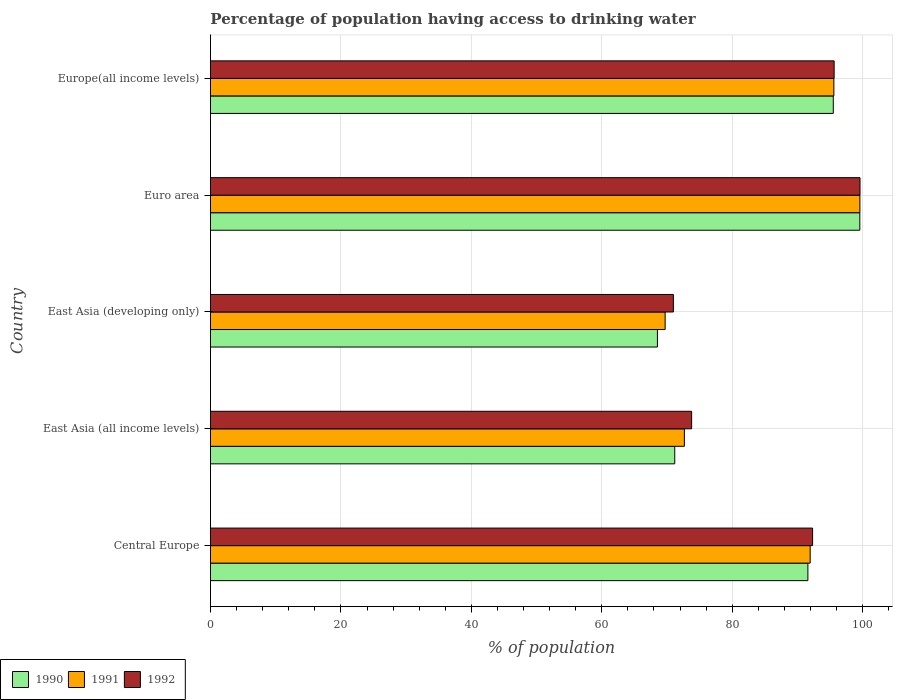How many different coloured bars are there?
Offer a terse response. 3. How many groups of bars are there?
Keep it short and to the point. 5. Are the number of bars on each tick of the Y-axis equal?
Offer a very short reply. Yes. How many bars are there on the 5th tick from the bottom?
Offer a very short reply. 3. What is the label of the 4th group of bars from the top?
Provide a succinct answer. East Asia (all income levels). What is the percentage of population having access to drinking water in 1990 in East Asia (all income levels)?
Provide a succinct answer. 71.19. Across all countries, what is the maximum percentage of population having access to drinking water in 1990?
Keep it short and to the point. 99.57. Across all countries, what is the minimum percentage of population having access to drinking water in 1992?
Your answer should be compact. 70.98. In which country was the percentage of population having access to drinking water in 1990 minimum?
Offer a terse response. East Asia (developing only). What is the total percentage of population having access to drinking water in 1990 in the graph?
Provide a short and direct response. 426.38. What is the difference between the percentage of population having access to drinking water in 1991 in Euro area and that in Europe(all income levels)?
Keep it short and to the point. 3.99. What is the difference between the percentage of population having access to drinking water in 1991 in East Asia (all income levels) and the percentage of population having access to drinking water in 1992 in East Asia (developing only)?
Ensure brevity in your answer.  1.69. What is the average percentage of population having access to drinking water in 1991 per country?
Your response must be concise. 85.9. What is the difference between the percentage of population having access to drinking water in 1990 and percentage of population having access to drinking water in 1992 in East Asia (developing only)?
Give a very brief answer. -2.44. In how many countries, is the percentage of population having access to drinking water in 1990 greater than 76 %?
Make the answer very short. 3. What is the ratio of the percentage of population having access to drinking water in 1992 in East Asia (all income levels) to that in East Asia (developing only)?
Give a very brief answer. 1.04. Is the difference between the percentage of population having access to drinking water in 1990 in Central Europe and East Asia (all income levels) greater than the difference between the percentage of population having access to drinking water in 1992 in Central Europe and East Asia (all income levels)?
Offer a very short reply. Yes. What is the difference between the highest and the second highest percentage of population having access to drinking water in 1992?
Your answer should be very brief. 3.97. What is the difference between the highest and the lowest percentage of population having access to drinking water in 1990?
Keep it short and to the point. 31.03. What does the 2nd bar from the top in Europe(all income levels) represents?
Give a very brief answer. 1991. Are all the bars in the graph horizontal?
Provide a short and direct response. Yes. What is the difference between two consecutive major ticks on the X-axis?
Provide a short and direct response. 20. Does the graph contain grids?
Your response must be concise. Yes. Where does the legend appear in the graph?
Your answer should be compact. Bottom left. How are the legend labels stacked?
Your answer should be compact. Horizontal. What is the title of the graph?
Ensure brevity in your answer.  Percentage of population having access to drinking water. Does "1976" appear as one of the legend labels in the graph?
Provide a succinct answer. No. What is the label or title of the X-axis?
Offer a very short reply. % of population. What is the % of population of 1990 in Central Europe?
Provide a short and direct response. 91.6. What is the % of population in 1991 in Central Europe?
Your response must be concise. 91.95. What is the % of population of 1992 in Central Europe?
Your answer should be compact. 92.32. What is the % of population in 1990 in East Asia (all income levels)?
Offer a very short reply. 71.19. What is the % of population in 1991 in East Asia (all income levels)?
Offer a very short reply. 72.66. What is the % of population in 1992 in East Asia (all income levels)?
Your response must be concise. 73.78. What is the % of population of 1990 in East Asia (developing only)?
Provide a short and direct response. 68.53. What is the % of population of 1991 in East Asia (developing only)?
Provide a short and direct response. 69.71. What is the % of population in 1992 in East Asia (developing only)?
Provide a short and direct response. 70.98. What is the % of population of 1990 in Euro area?
Offer a very short reply. 99.57. What is the % of population of 1991 in Euro area?
Give a very brief answer. 99.58. What is the % of population of 1992 in Euro area?
Your answer should be very brief. 99.6. What is the % of population in 1990 in Europe(all income levels)?
Offer a terse response. 95.5. What is the % of population in 1991 in Europe(all income levels)?
Your response must be concise. 95.59. What is the % of population of 1992 in Europe(all income levels)?
Offer a very short reply. 95.63. Across all countries, what is the maximum % of population in 1990?
Offer a very short reply. 99.57. Across all countries, what is the maximum % of population in 1991?
Your answer should be very brief. 99.58. Across all countries, what is the maximum % of population in 1992?
Your answer should be very brief. 99.6. Across all countries, what is the minimum % of population in 1990?
Offer a terse response. 68.53. Across all countries, what is the minimum % of population of 1991?
Ensure brevity in your answer.  69.71. Across all countries, what is the minimum % of population of 1992?
Your response must be concise. 70.98. What is the total % of population in 1990 in the graph?
Offer a terse response. 426.38. What is the total % of population in 1991 in the graph?
Your answer should be very brief. 429.5. What is the total % of population in 1992 in the graph?
Your answer should be compact. 432.3. What is the difference between the % of population in 1990 in Central Europe and that in East Asia (all income levels)?
Make the answer very short. 20.41. What is the difference between the % of population in 1991 in Central Europe and that in East Asia (all income levels)?
Offer a terse response. 19.29. What is the difference between the % of population in 1992 in Central Europe and that in East Asia (all income levels)?
Provide a succinct answer. 18.55. What is the difference between the % of population of 1990 in Central Europe and that in East Asia (developing only)?
Give a very brief answer. 23.07. What is the difference between the % of population in 1991 in Central Europe and that in East Asia (developing only)?
Your answer should be very brief. 22.24. What is the difference between the % of population in 1992 in Central Europe and that in East Asia (developing only)?
Give a very brief answer. 21.35. What is the difference between the % of population of 1990 in Central Europe and that in Euro area?
Make the answer very short. -7.96. What is the difference between the % of population of 1991 in Central Europe and that in Euro area?
Your response must be concise. -7.63. What is the difference between the % of population in 1992 in Central Europe and that in Euro area?
Your response must be concise. -7.27. What is the difference between the % of population of 1990 in Central Europe and that in Europe(all income levels)?
Make the answer very short. -3.9. What is the difference between the % of population in 1991 in Central Europe and that in Europe(all income levels)?
Provide a short and direct response. -3.64. What is the difference between the % of population of 1992 in Central Europe and that in Europe(all income levels)?
Offer a terse response. -3.3. What is the difference between the % of population in 1990 in East Asia (all income levels) and that in East Asia (developing only)?
Your response must be concise. 2.66. What is the difference between the % of population of 1991 in East Asia (all income levels) and that in East Asia (developing only)?
Ensure brevity in your answer.  2.95. What is the difference between the % of population in 1992 in East Asia (all income levels) and that in East Asia (developing only)?
Provide a short and direct response. 2.8. What is the difference between the % of population in 1990 in East Asia (all income levels) and that in Euro area?
Your response must be concise. -28.38. What is the difference between the % of population in 1991 in East Asia (all income levels) and that in Euro area?
Ensure brevity in your answer.  -26.92. What is the difference between the % of population of 1992 in East Asia (all income levels) and that in Euro area?
Give a very brief answer. -25.82. What is the difference between the % of population in 1990 in East Asia (all income levels) and that in Europe(all income levels)?
Ensure brevity in your answer.  -24.31. What is the difference between the % of population in 1991 in East Asia (all income levels) and that in Europe(all income levels)?
Your response must be concise. -22.92. What is the difference between the % of population in 1992 in East Asia (all income levels) and that in Europe(all income levels)?
Offer a terse response. -21.85. What is the difference between the % of population in 1990 in East Asia (developing only) and that in Euro area?
Offer a very short reply. -31.03. What is the difference between the % of population in 1991 in East Asia (developing only) and that in Euro area?
Ensure brevity in your answer.  -29.86. What is the difference between the % of population of 1992 in East Asia (developing only) and that in Euro area?
Provide a succinct answer. -28.62. What is the difference between the % of population of 1990 in East Asia (developing only) and that in Europe(all income levels)?
Provide a succinct answer. -26.96. What is the difference between the % of population of 1991 in East Asia (developing only) and that in Europe(all income levels)?
Your answer should be compact. -25.87. What is the difference between the % of population of 1992 in East Asia (developing only) and that in Europe(all income levels)?
Keep it short and to the point. -24.65. What is the difference between the % of population of 1990 in Euro area and that in Europe(all income levels)?
Make the answer very short. 4.07. What is the difference between the % of population in 1991 in Euro area and that in Europe(all income levels)?
Offer a very short reply. 3.99. What is the difference between the % of population in 1992 in Euro area and that in Europe(all income levels)?
Provide a succinct answer. 3.97. What is the difference between the % of population of 1990 in Central Europe and the % of population of 1991 in East Asia (all income levels)?
Provide a succinct answer. 18.94. What is the difference between the % of population of 1990 in Central Europe and the % of population of 1992 in East Asia (all income levels)?
Your answer should be compact. 17.83. What is the difference between the % of population of 1991 in Central Europe and the % of population of 1992 in East Asia (all income levels)?
Provide a short and direct response. 18.18. What is the difference between the % of population in 1990 in Central Europe and the % of population in 1991 in East Asia (developing only)?
Offer a terse response. 21.89. What is the difference between the % of population of 1990 in Central Europe and the % of population of 1992 in East Asia (developing only)?
Give a very brief answer. 20.62. What is the difference between the % of population of 1991 in Central Europe and the % of population of 1992 in East Asia (developing only)?
Ensure brevity in your answer.  20.98. What is the difference between the % of population of 1990 in Central Europe and the % of population of 1991 in Euro area?
Give a very brief answer. -7.98. What is the difference between the % of population in 1990 in Central Europe and the % of population in 1992 in Euro area?
Provide a short and direct response. -7.99. What is the difference between the % of population of 1991 in Central Europe and the % of population of 1992 in Euro area?
Your answer should be compact. -7.64. What is the difference between the % of population in 1990 in Central Europe and the % of population in 1991 in Europe(all income levels)?
Ensure brevity in your answer.  -3.99. What is the difference between the % of population of 1990 in Central Europe and the % of population of 1992 in Europe(all income levels)?
Provide a short and direct response. -4.03. What is the difference between the % of population in 1991 in Central Europe and the % of population in 1992 in Europe(all income levels)?
Your answer should be compact. -3.68. What is the difference between the % of population of 1990 in East Asia (all income levels) and the % of population of 1991 in East Asia (developing only)?
Provide a succinct answer. 1.47. What is the difference between the % of population of 1990 in East Asia (all income levels) and the % of population of 1992 in East Asia (developing only)?
Your answer should be compact. 0.21. What is the difference between the % of population of 1991 in East Asia (all income levels) and the % of population of 1992 in East Asia (developing only)?
Your response must be concise. 1.69. What is the difference between the % of population in 1990 in East Asia (all income levels) and the % of population in 1991 in Euro area?
Give a very brief answer. -28.39. What is the difference between the % of population of 1990 in East Asia (all income levels) and the % of population of 1992 in Euro area?
Offer a terse response. -28.41. What is the difference between the % of population in 1991 in East Asia (all income levels) and the % of population in 1992 in Euro area?
Make the answer very short. -26.93. What is the difference between the % of population in 1990 in East Asia (all income levels) and the % of population in 1991 in Europe(all income levels)?
Give a very brief answer. -24.4. What is the difference between the % of population of 1990 in East Asia (all income levels) and the % of population of 1992 in Europe(all income levels)?
Provide a succinct answer. -24.44. What is the difference between the % of population in 1991 in East Asia (all income levels) and the % of population in 1992 in Europe(all income levels)?
Give a very brief answer. -22.96. What is the difference between the % of population in 1990 in East Asia (developing only) and the % of population in 1991 in Euro area?
Your answer should be compact. -31.05. What is the difference between the % of population in 1990 in East Asia (developing only) and the % of population in 1992 in Euro area?
Give a very brief answer. -31.06. What is the difference between the % of population in 1991 in East Asia (developing only) and the % of population in 1992 in Euro area?
Ensure brevity in your answer.  -29.88. What is the difference between the % of population in 1990 in East Asia (developing only) and the % of population in 1991 in Europe(all income levels)?
Your response must be concise. -27.06. What is the difference between the % of population of 1990 in East Asia (developing only) and the % of population of 1992 in Europe(all income levels)?
Provide a short and direct response. -27.1. What is the difference between the % of population of 1991 in East Asia (developing only) and the % of population of 1992 in Europe(all income levels)?
Offer a very short reply. -25.91. What is the difference between the % of population of 1990 in Euro area and the % of population of 1991 in Europe(all income levels)?
Provide a succinct answer. 3.98. What is the difference between the % of population in 1990 in Euro area and the % of population in 1992 in Europe(all income levels)?
Your answer should be very brief. 3.94. What is the difference between the % of population in 1991 in Euro area and the % of population in 1992 in Europe(all income levels)?
Your answer should be very brief. 3.95. What is the average % of population of 1990 per country?
Offer a very short reply. 85.28. What is the average % of population in 1991 per country?
Ensure brevity in your answer.  85.9. What is the average % of population of 1992 per country?
Keep it short and to the point. 86.46. What is the difference between the % of population of 1990 and % of population of 1991 in Central Europe?
Keep it short and to the point. -0.35. What is the difference between the % of population of 1990 and % of population of 1992 in Central Europe?
Provide a succinct answer. -0.72. What is the difference between the % of population of 1991 and % of population of 1992 in Central Europe?
Provide a short and direct response. -0.37. What is the difference between the % of population of 1990 and % of population of 1991 in East Asia (all income levels)?
Offer a terse response. -1.48. What is the difference between the % of population in 1990 and % of population in 1992 in East Asia (all income levels)?
Your response must be concise. -2.59. What is the difference between the % of population of 1991 and % of population of 1992 in East Asia (all income levels)?
Offer a terse response. -1.11. What is the difference between the % of population of 1990 and % of population of 1991 in East Asia (developing only)?
Give a very brief answer. -1.18. What is the difference between the % of population of 1990 and % of population of 1992 in East Asia (developing only)?
Give a very brief answer. -2.44. What is the difference between the % of population in 1991 and % of population in 1992 in East Asia (developing only)?
Provide a short and direct response. -1.26. What is the difference between the % of population of 1990 and % of population of 1991 in Euro area?
Ensure brevity in your answer.  -0.01. What is the difference between the % of population in 1990 and % of population in 1992 in Euro area?
Ensure brevity in your answer.  -0.03. What is the difference between the % of population in 1991 and % of population in 1992 in Euro area?
Your answer should be very brief. -0.02. What is the difference between the % of population in 1990 and % of population in 1991 in Europe(all income levels)?
Your response must be concise. -0.09. What is the difference between the % of population of 1990 and % of population of 1992 in Europe(all income levels)?
Your answer should be very brief. -0.13. What is the difference between the % of population of 1991 and % of population of 1992 in Europe(all income levels)?
Provide a short and direct response. -0.04. What is the ratio of the % of population in 1990 in Central Europe to that in East Asia (all income levels)?
Your response must be concise. 1.29. What is the ratio of the % of population in 1991 in Central Europe to that in East Asia (all income levels)?
Provide a succinct answer. 1.27. What is the ratio of the % of population of 1992 in Central Europe to that in East Asia (all income levels)?
Keep it short and to the point. 1.25. What is the ratio of the % of population of 1990 in Central Europe to that in East Asia (developing only)?
Your response must be concise. 1.34. What is the ratio of the % of population in 1991 in Central Europe to that in East Asia (developing only)?
Give a very brief answer. 1.32. What is the ratio of the % of population of 1992 in Central Europe to that in East Asia (developing only)?
Keep it short and to the point. 1.3. What is the ratio of the % of population in 1990 in Central Europe to that in Euro area?
Give a very brief answer. 0.92. What is the ratio of the % of population of 1991 in Central Europe to that in Euro area?
Your response must be concise. 0.92. What is the ratio of the % of population in 1992 in Central Europe to that in Euro area?
Provide a succinct answer. 0.93. What is the ratio of the % of population of 1990 in Central Europe to that in Europe(all income levels)?
Ensure brevity in your answer.  0.96. What is the ratio of the % of population in 1992 in Central Europe to that in Europe(all income levels)?
Make the answer very short. 0.97. What is the ratio of the % of population of 1990 in East Asia (all income levels) to that in East Asia (developing only)?
Provide a short and direct response. 1.04. What is the ratio of the % of population in 1991 in East Asia (all income levels) to that in East Asia (developing only)?
Your answer should be compact. 1.04. What is the ratio of the % of population in 1992 in East Asia (all income levels) to that in East Asia (developing only)?
Offer a very short reply. 1.04. What is the ratio of the % of population of 1990 in East Asia (all income levels) to that in Euro area?
Your answer should be very brief. 0.71. What is the ratio of the % of population of 1991 in East Asia (all income levels) to that in Euro area?
Your response must be concise. 0.73. What is the ratio of the % of population of 1992 in East Asia (all income levels) to that in Euro area?
Your response must be concise. 0.74. What is the ratio of the % of population of 1990 in East Asia (all income levels) to that in Europe(all income levels)?
Ensure brevity in your answer.  0.75. What is the ratio of the % of population of 1991 in East Asia (all income levels) to that in Europe(all income levels)?
Give a very brief answer. 0.76. What is the ratio of the % of population in 1992 in East Asia (all income levels) to that in Europe(all income levels)?
Your answer should be compact. 0.77. What is the ratio of the % of population of 1990 in East Asia (developing only) to that in Euro area?
Provide a short and direct response. 0.69. What is the ratio of the % of population of 1991 in East Asia (developing only) to that in Euro area?
Your response must be concise. 0.7. What is the ratio of the % of population of 1992 in East Asia (developing only) to that in Euro area?
Give a very brief answer. 0.71. What is the ratio of the % of population in 1990 in East Asia (developing only) to that in Europe(all income levels)?
Your answer should be compact. 0.72. What is the ratio of the % of population in 1991 in East Asia (developing only) to that in Europe(all income levels)?
Your response must be concise. 0.73. What is the ratio of the % of population in 1992 in East Asia (developing only) to that in Europe(all income levels)?
Your answer should be compact. 0.74. What is the ratio of the % of population of 1990 in Euro area to that in Europe(all income levels)?
Make the answer very short. 1.04. What is the ratio of the % of population of 1991 in Euro area to that in Europe(all income levels)?
Your answer should be compact. 1.04. What is the ratio of the % of population in 1992 in Euro area to that in Europe(all income levels)?
Keep it short and to the point. 1.04. What is the difference between the highest and the second highest % of population in 1990?
Give a very brief answer. 4.07. What is the difference between the highest and the second highest % of population of 1991?
Ensure brevity in your answer.  3.99. What is the difference between the highest and the second highest % of population of 1992?
Your response must be concise. 3.97. What is the difference between the highest and the lowest % of population in 1990?
Offer a terse response. 31.03. What is the difference between the highest and the lowest % of population in 1991?
Keep it short and to the point. 29.86. What is the difference between the highest and the lowest % of population in 1992?
Your answer should be very brief. 28.62. 